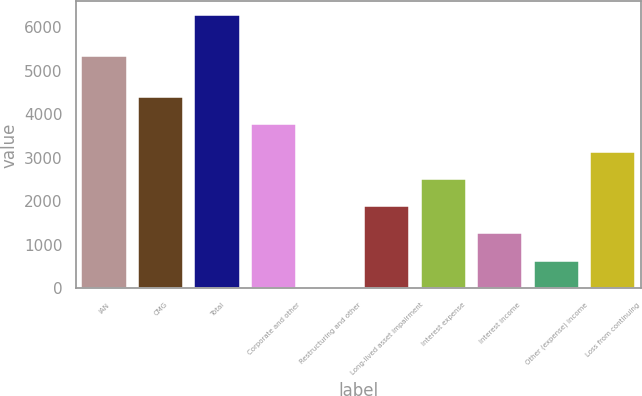Convert chart. <chart><loc_0><loc_0><loc_500><loc_500><bar_chart><fcel>IAN<fcel>CMG<fcel>Total<fcel>Corporate and other<fcel>Restructuring and other<fcel>Long-lived asset impairment<fcel>Interest expense<fcel>Interest income<fcel>Other (expense) income<fcel>Loss from continuing<nl><fcel>5327.8<fcel>4394.2<fcel>6274.3<fcel>3767.5<fcel>7.3<fcel>1887.4<fcel>2514.1<fcel>1260.7<fcel>634<fcel>3140.8<nl></chart> 